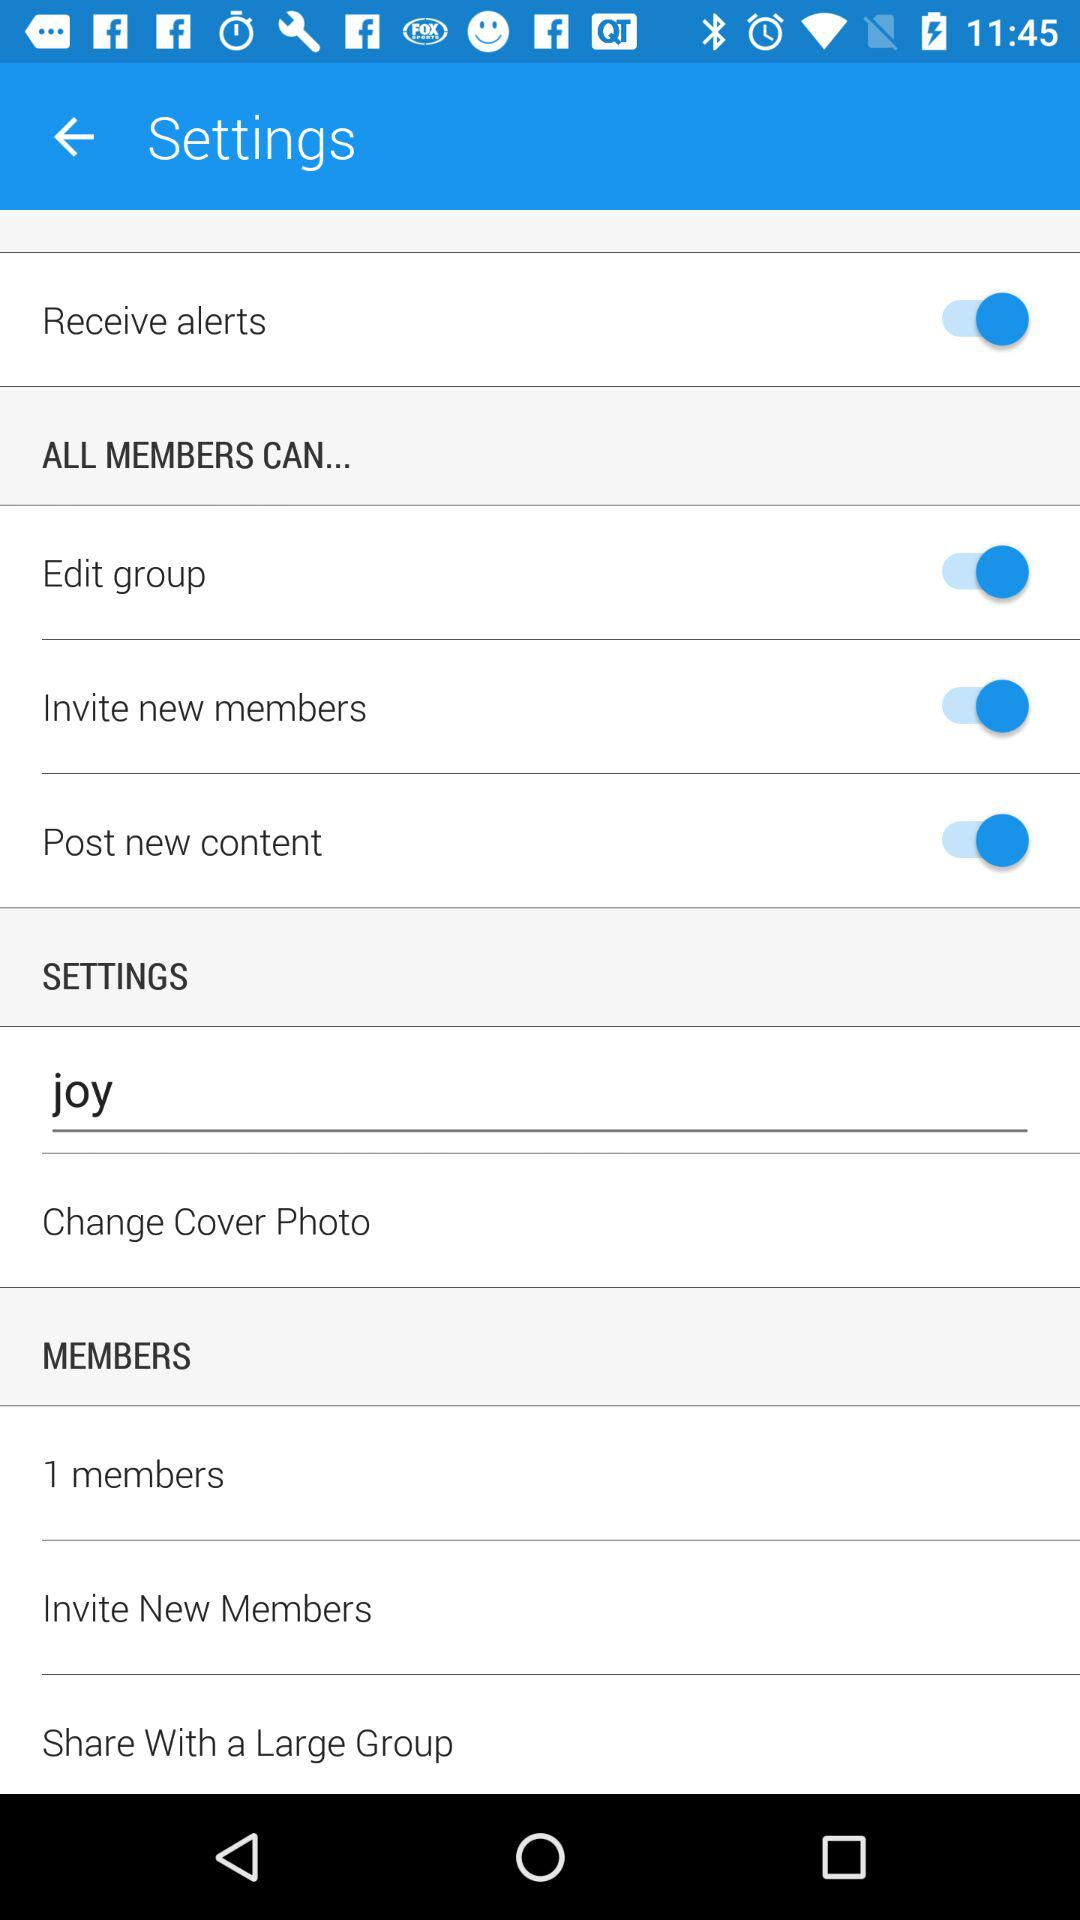What is the status of the "Edit group"? The status is "on". 